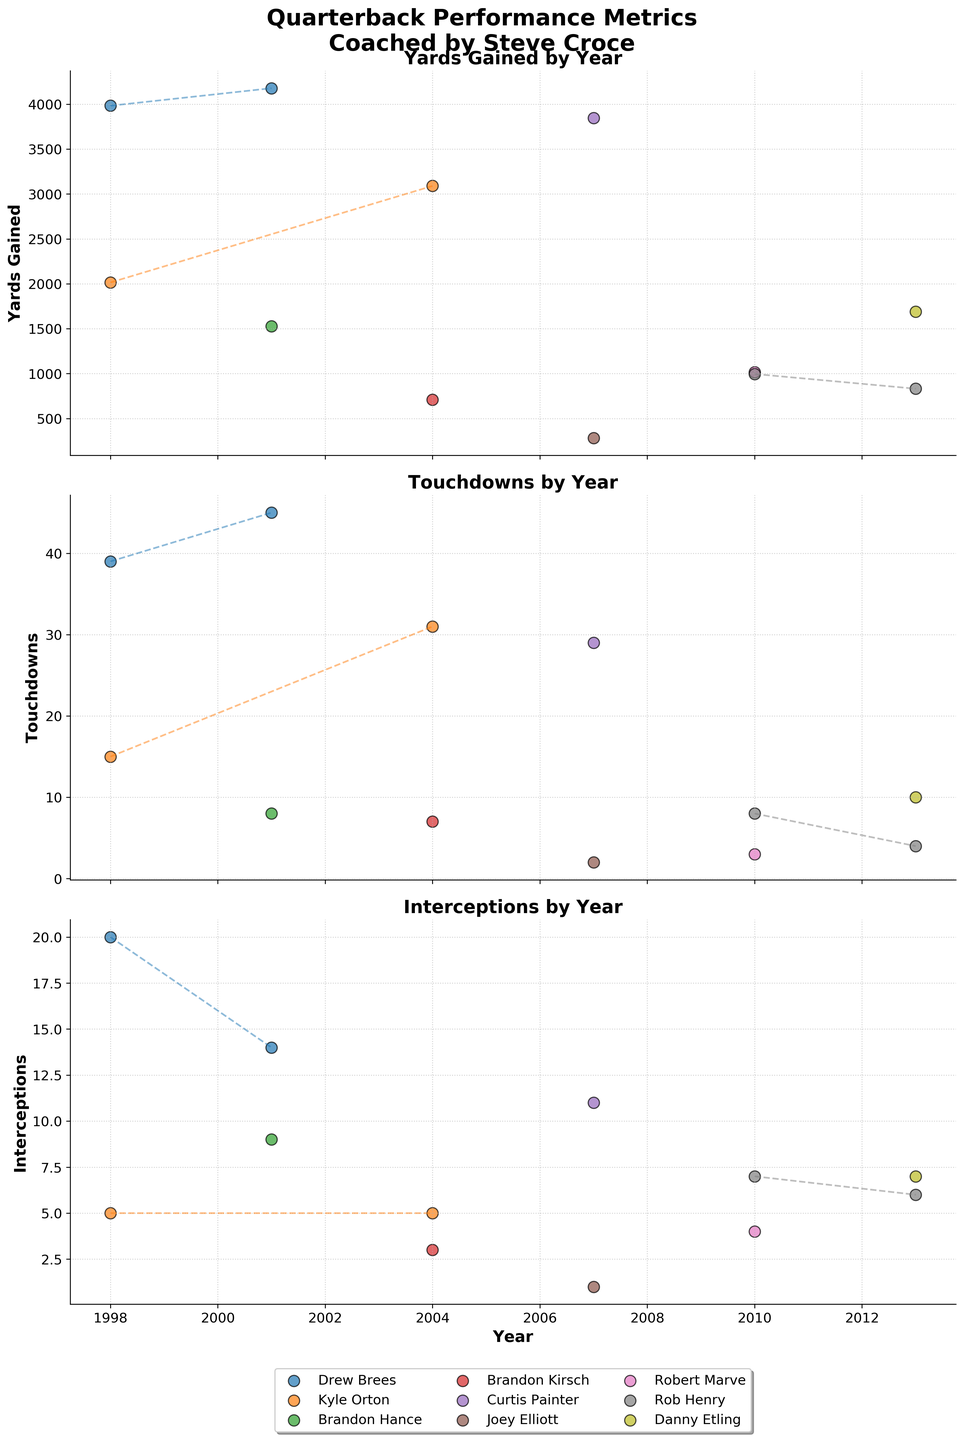What is the title of the figure? The title of the figure is displayed at the top in bold font: "Quarterback Performance Metrics\nCoached by Steve Croce".
Answer: Quarterback Performance Metrics\nCoached by Steve Croce Which year does Drew Brees have the highest Yards Gained? To find the year where Drew Brees has the highest Yards Gained, we look for the highest scatter point for Drew Brees in the "Yards Gained" subplot. It appears that Drew Brees has the highest Yards Gained in 2001.
Answer: 2001 How many different quarterbacks are plotted in the figure? By counting the unique labels in the legend below the "Interceptions" subplot, we can see there are 9 different quarterbacks: Drew Brees, Kyle Orton, Brandon Hance, Brandon Kirsch, Curtis Painter, Joey Elliott, Robert Marve, Rob Henry, and Danny Etling.
Answer: 9 Which quarterback had the most Touchdowns in a single year? To find the quarterback with the most Touchdowns in a single year, we look at the highest scatter point in the "Touchdowns" subplot. Drew Brees in 2001 has the highest point with 45 Touchdowns.
Answer: Drew Brees Between Robert Marve and Rob Henry, who had fewer Interceptions in 2010? Comparing the scatter points for Robert Marve and Rob Henry in the "Interceptions" subplot for the year 2010, Robert Marve had 4 interceptions while Rob Henry had 7.
Answer: Robert Marve Which year had the highest total Yards Gained by quarterbacks? To find the year with the highest total Yards Gained, sum up the Yards Gained for each year across all quarterbacks: - 1998: 3983 + 2015 = 5998 - 2001: 4178 + 1529 = 5707 - 2004: 3090 + 711 = 3801 - 2007: 3846 + 284 = 4130 - 2010: 1017 + 996 = 2013 - 2013: 1690 + 832 = 2522 The year 1998 had the highest total with 5998 Yards Gained.
Answer: 1998 Did any quarterback have 0 Interceptions in any year? By observing the "Interceptions" subplot, we see that every scatter point is above 0, indicating no quarterback had 0 Interceptions in any year.
Answer: No In which year did Curtis Painter start playing as a quarterback under Coach Steve Croce? By looking at the scatter points labeled Curtis Painter across all subplots, the only year that Curtis Painter appears is 2007.
Answer: 2007 Who gained more yards in 2004, Kyle Orton or Brandon Kirsch? By comparing the scatter points for 2004 in the "Yards Gained" subplot, Kyle Orton gained 3090 yards, while Brandon Kirsch gained 711 yards.
Answer: Kyle Orton 